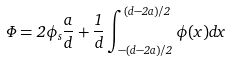<formula> <loc_0><loc_0><loc_500><loc_500>\Phi = 2 \phi _ { s } \frac { a } { d } + \frac { 1 } { d } \int _ { - ( d - 2 a ) / 2 } ^ { ( d - 2 a ) / 2 } \phi ( x ) d x</formula> 